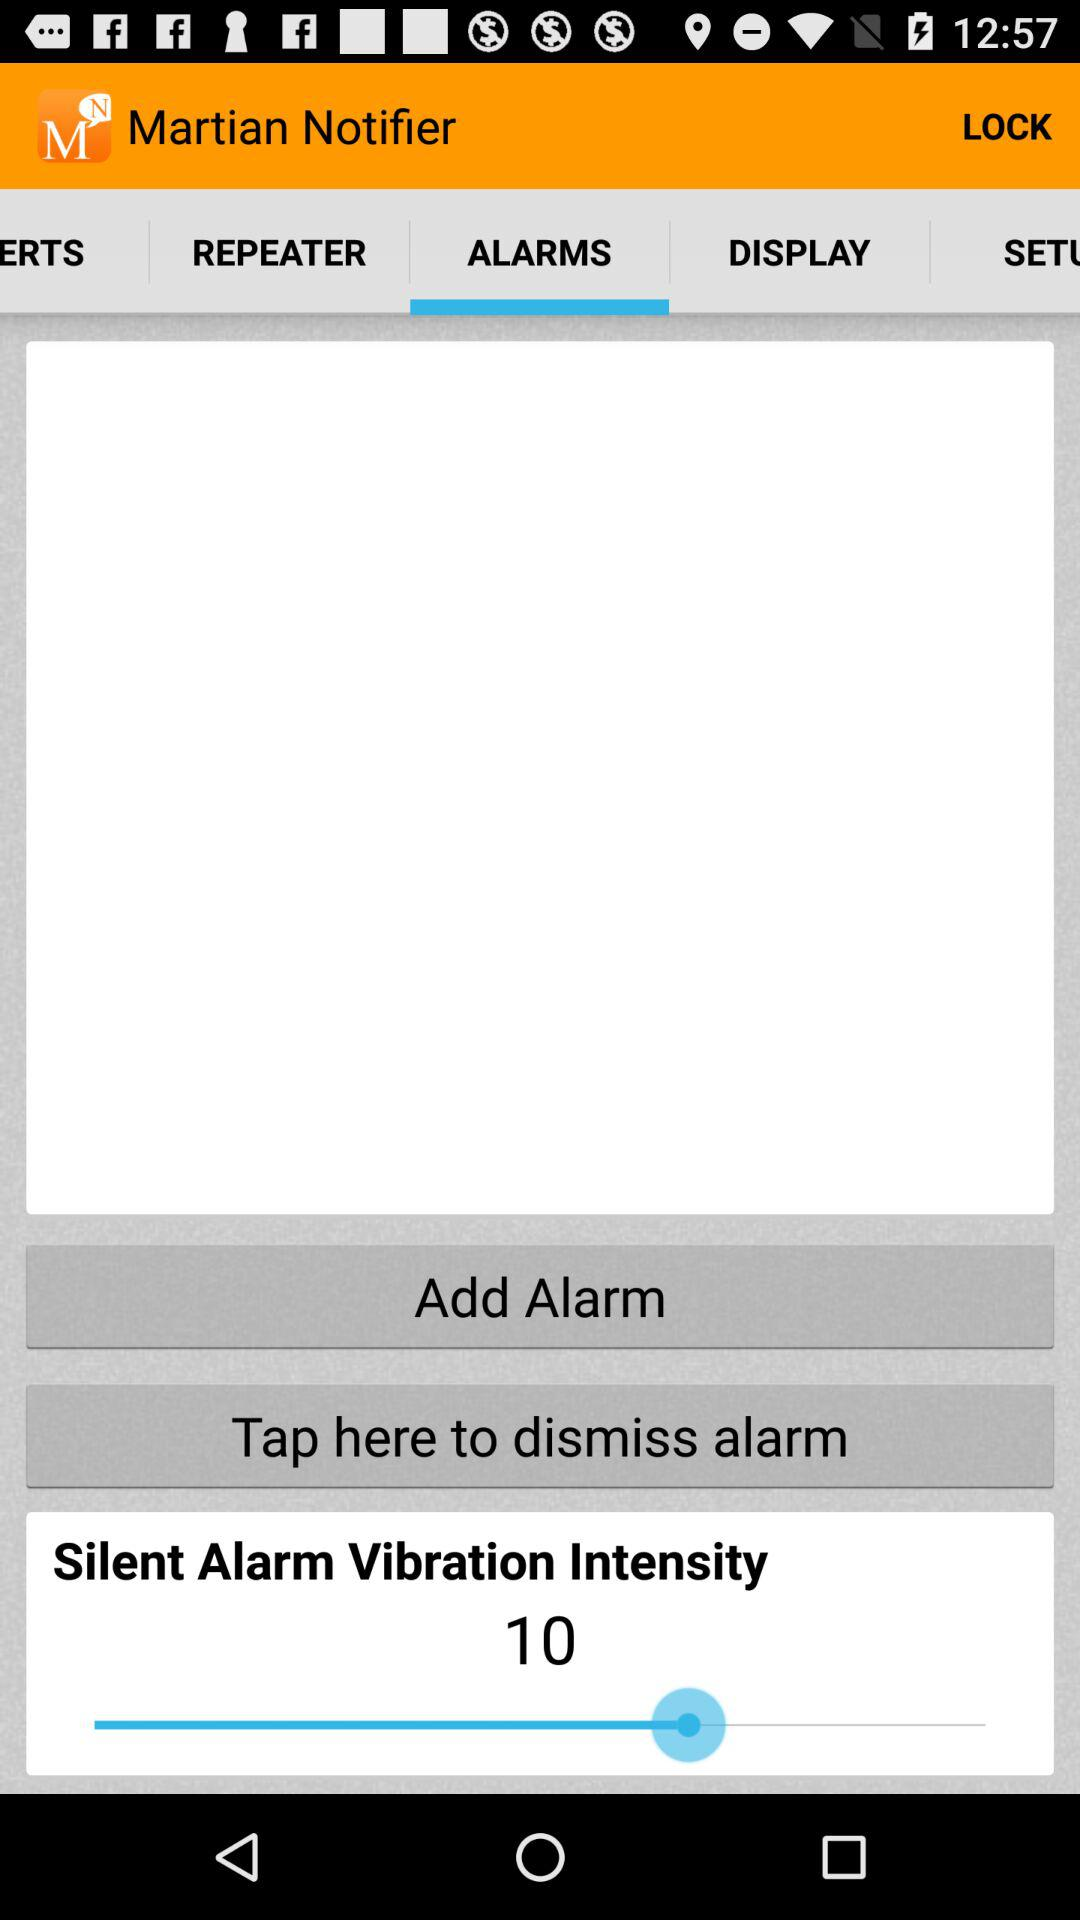What is the selected alarm vibration intensity? The selected alarm vibration intensity is 10. 